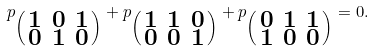<formula> <loc_0><loc_0><loc_500><loc_500>p _ { \left ( \begin{smallmatrix} 1 & 0 & 1 \\ 0 & 1 & 0 \end{smallmatrix} \right ) } + p _ { \left ( \begin{smallmatrix} 1 & 1 & 0 \\ 0 & 0 & 1 \end{smallmatrix} \right ) } + p _ { \left ( \begin{smallmatrix} 0 & 1 & 1 \\ 1 & 0 & 0 \end{smallmatrix} \right ) } = 0 .</formula> 